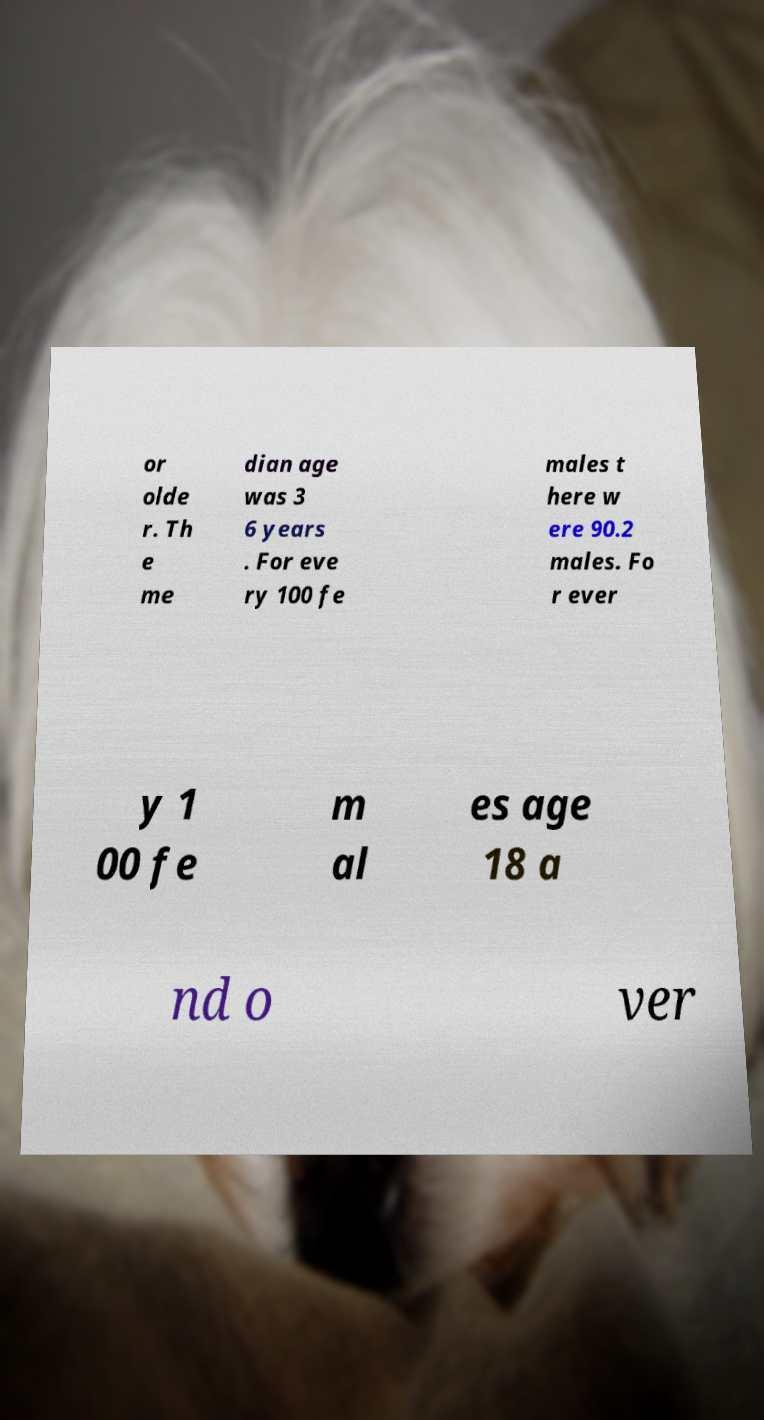Can you read and provide the text displayed in the image?This photo seems to have some interesting text. Can you extract and type it out for me? or olde r. Th e me dian age was 3 6 years . For eve ry 100 fe males t here w ere 90.2 males. Fo r ever y 1 00 fe m al es age 18 a nd o ver 